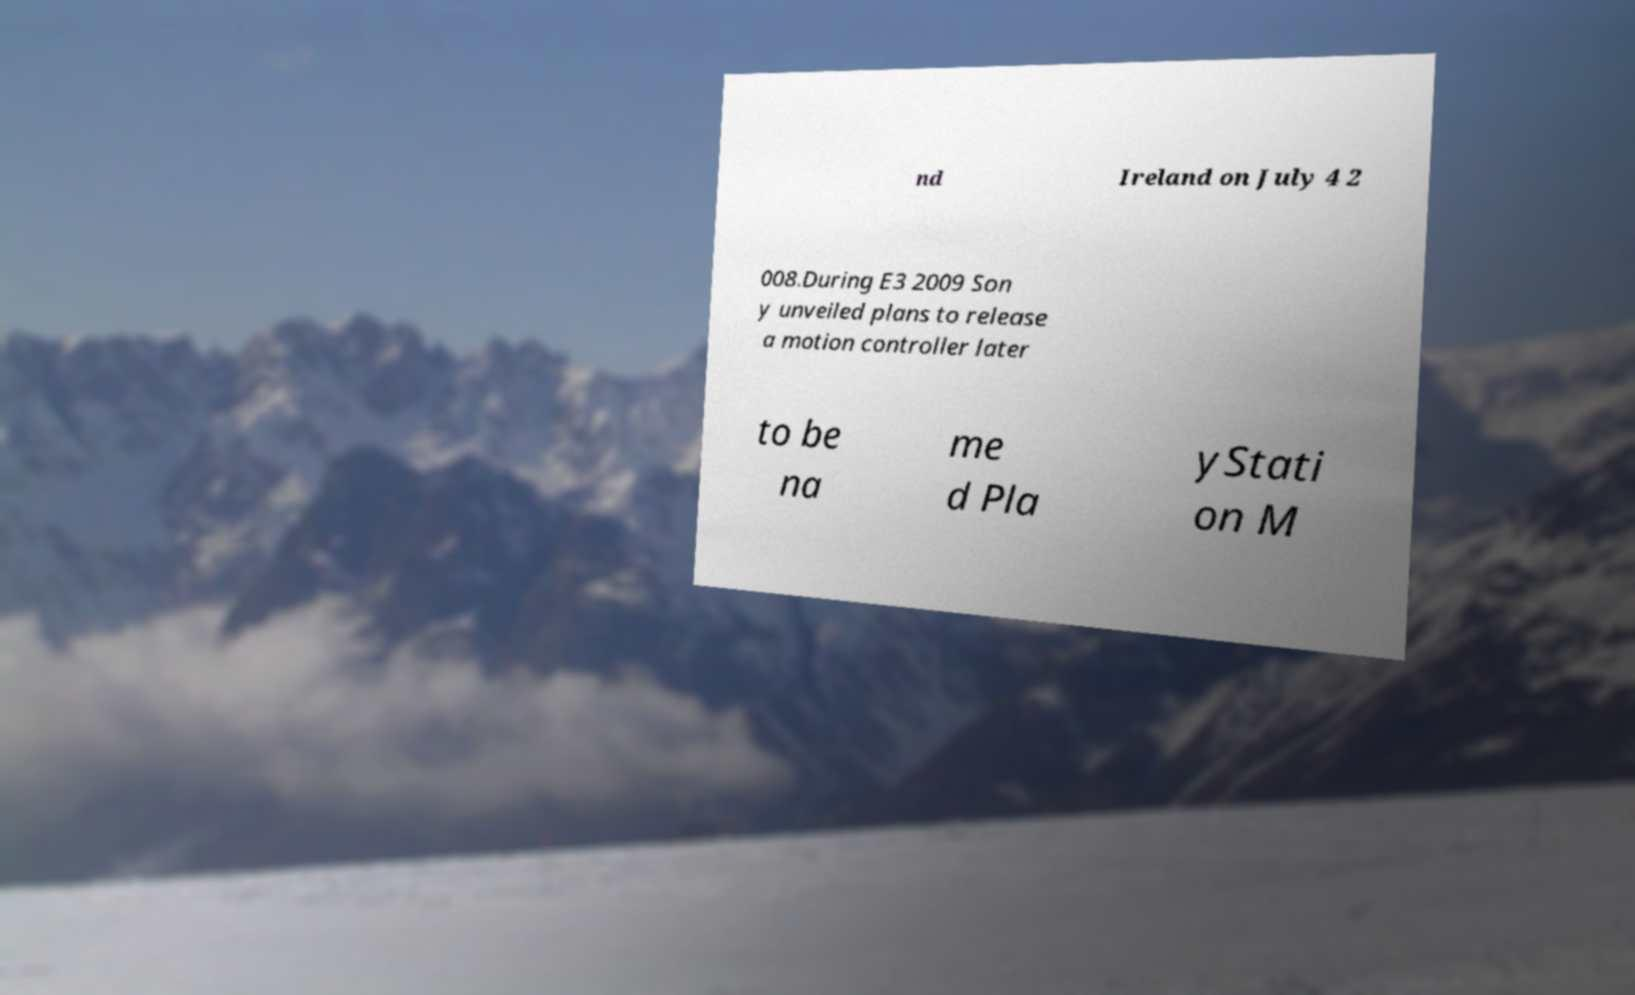For documentation purposes, I need the text within this image transcribed. Could you provide that? nd Ireland on July 4 2 008.During E3 2009 Son y unveiled plans to release a motion controller later to be na me d Pla yStati on M 